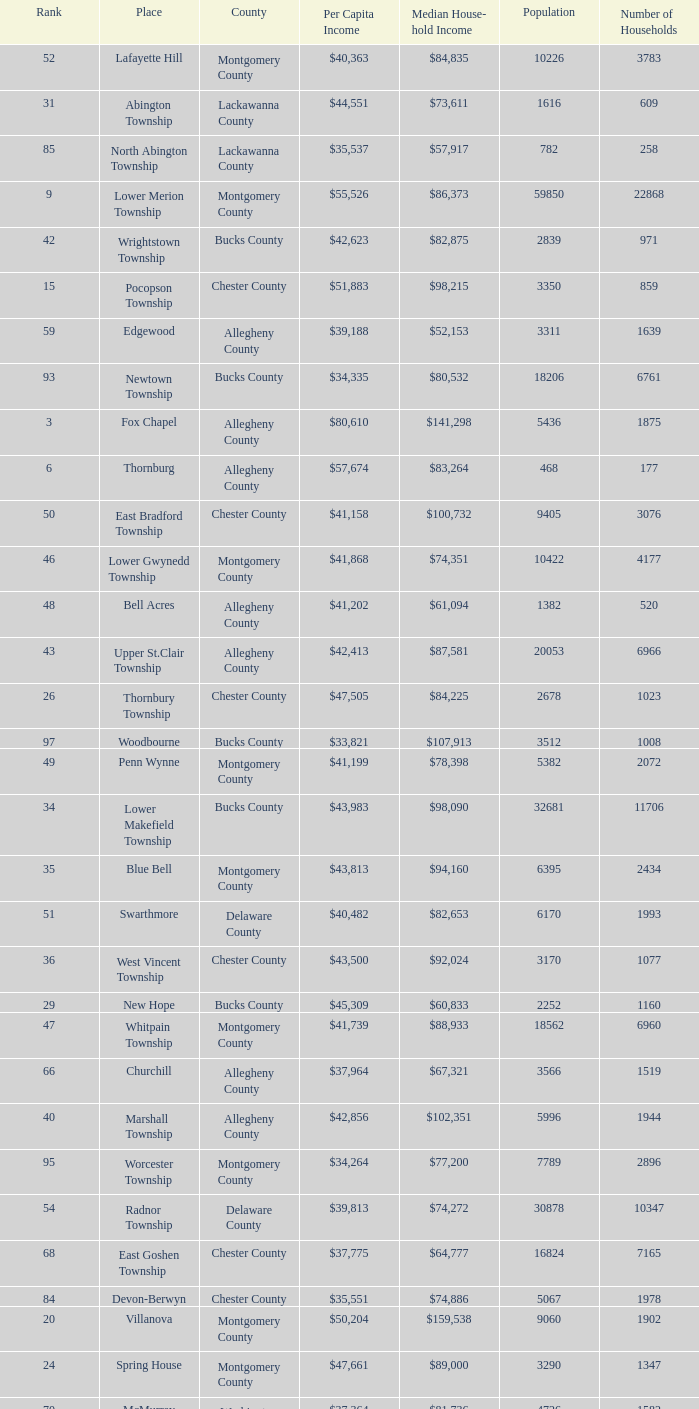What county has 2053 households?  Chester County. 